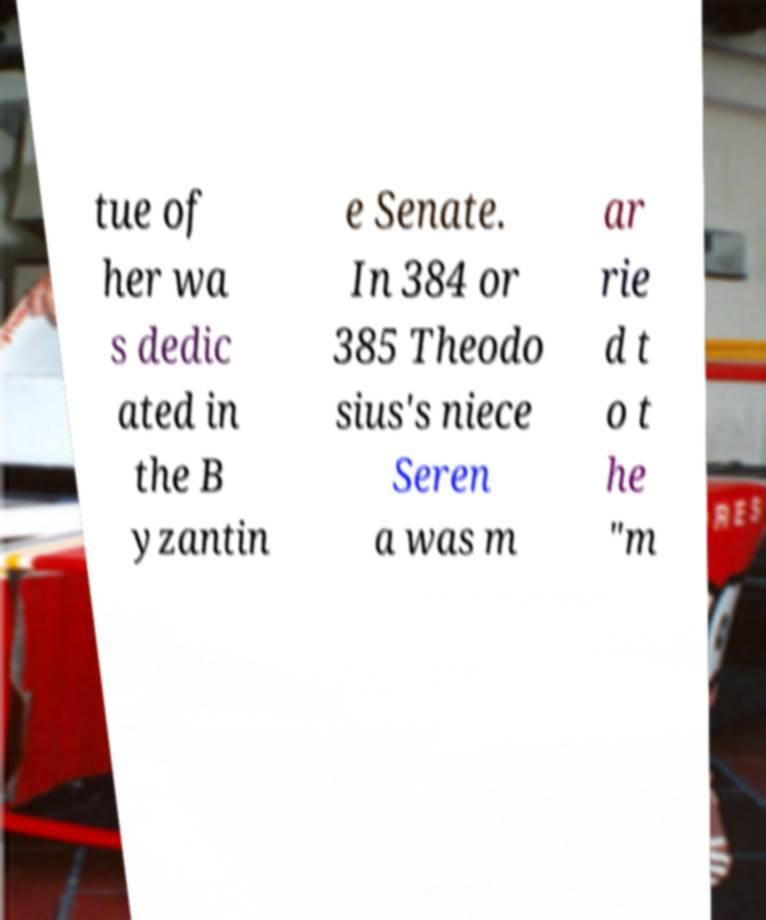I need the written content from this picture converted into text. Can you do that? tue of her wa s dedic ated in the B yzantin e Senate. In 384 or 385 Theodo sius's niece Seren a was m ar rie d t o t he "m 